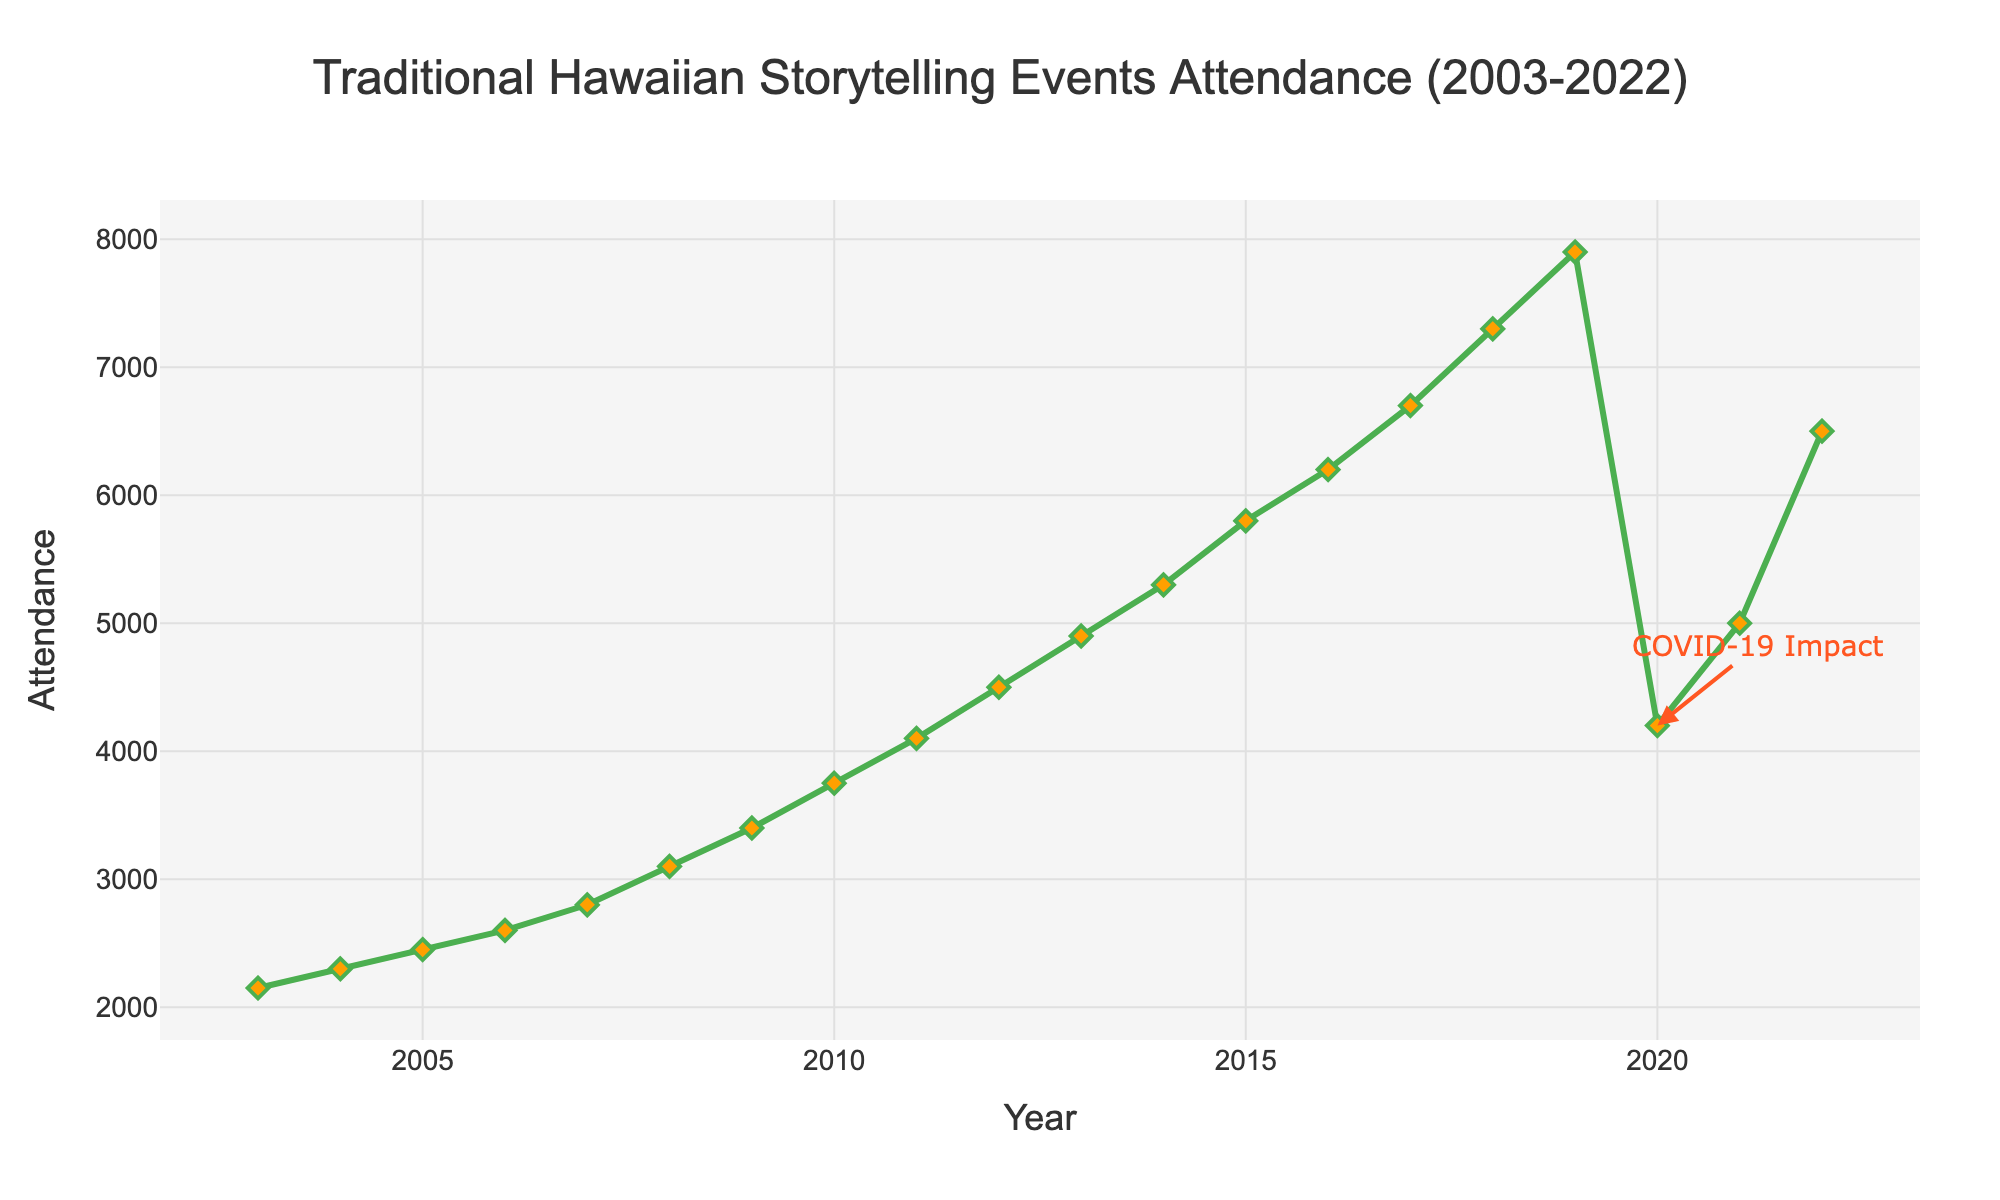What's the general trend in attendance for Traditional Hawaiian storytelling events from 2003 to 2019? The attendance generally increased every year from 2003 to 2019. This can be seen by a consistently upward line and increasing markers for each subsequent year.
Answer: Increased What significant event caused a notable drop in attendance in 2020? An annotation on the plot indicates "COVID-19 Impact" near the point for the year 2020, showing a significant drop from the previous year.
Answer: COVID-19 Impact Which year had the highest attendance for Traditional Hawaiian storytelling events? The highest attendance is indicated by the tallest point on the graph, which occurs in 2019.
Answer: 2019 How does the attendance in 2022 compare to the attendance in 2021? The point for 2022 is higher on the graph than the point for 2021, indicating an increase in attendance.
Answer: Increased What's the average attendance from 2003 to 2019? Sum the attendance values from 2003 to 2019 (2150 + 2300 + 2450 + 2600 + 2800 + 3100 + 3400 + 3750 + 4100 + 4500 + 4900 + 5300 + 5800 + 6200 + 6700 + 7300 + 7900) which is 79650, then divide by the number of years (2019 - 2003 + 1) which is 17. 79650 / 17 = 4685.29
Answer: 4685.29 What is the overall percentage drop in attendance from 2019 to 2020? The attendance in 2019 is 7900 and in 2020 is 4200. The drop in attendance is 7900 - 4200 = 3700. The percentage drop is (3700 / 7900) * 100 = 46.84%
Answer: 46.84% What color is used to annotate the impact of COVID-19 on the chart? The annotation for COVID-19 Impact is in red, as noted by the visual highlighting it.
Answer: Red How many years saw an increase in attendance from the previous year between 2003 and 2019? Every year from 2003 to 2019 shows an increase in attendance as evidenced by successive upward points on the graph. Therefore, all 16 years have increasing attendance.
Answer: 16 During which years did the attendance surpass 7000? The attendance markers surpass 7000 for the years 2018 and 2019, as indicated by their positions above the 7000 line on the y-axis.
Answer: 2018 and 2019 Compare the attendance in 2010 and 2022. The point for 2022 is higher than the point for 2010, indicating that the attendance in 2022 (6500) is greater than in 2010 (3750).
Answer: 2022 is higher 